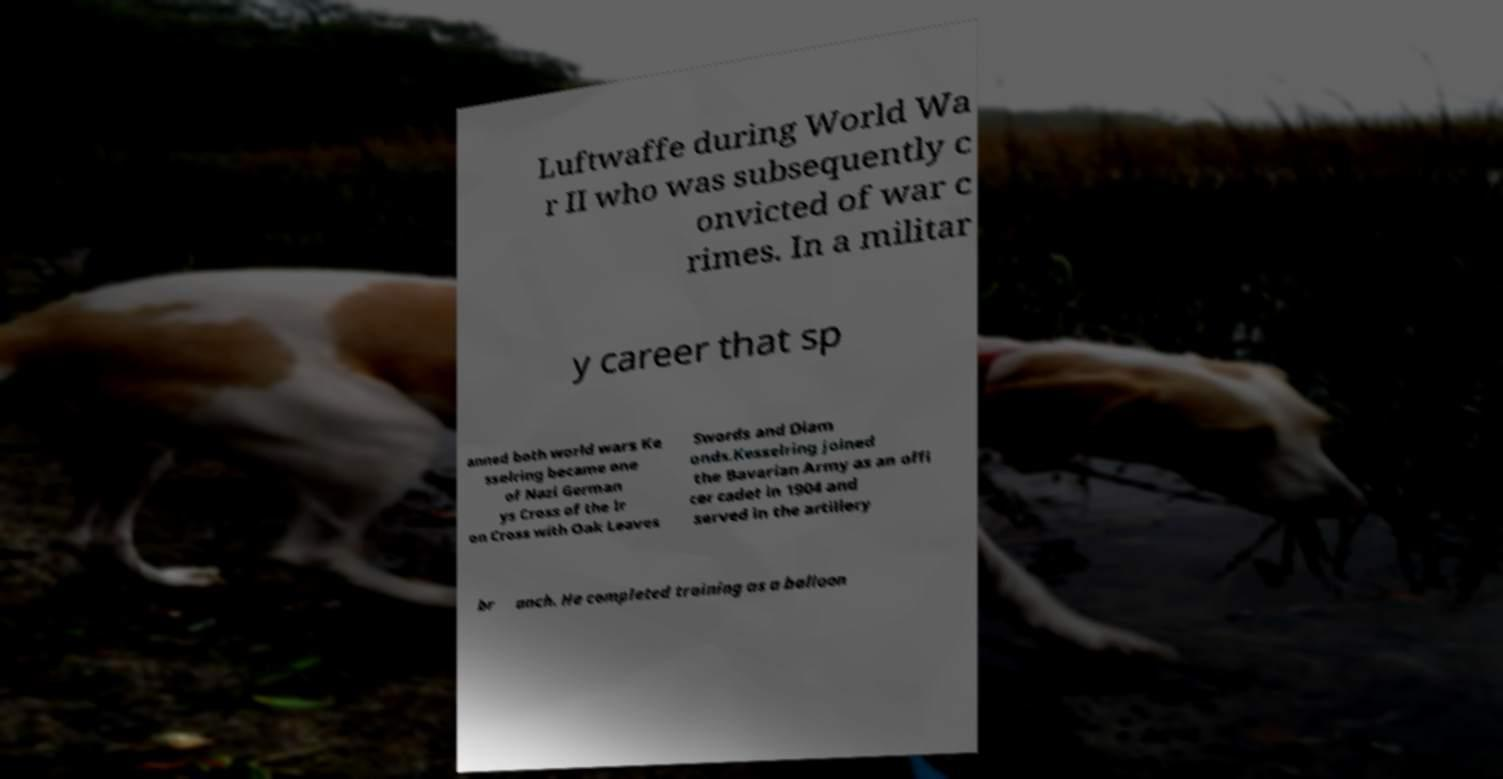Could you extract and type out the text from this image? Luftwaffe during World Wa r II who was subsequently c onvicted of war c rimes. In a militar y career that sp anned both world wars Ke sselring became one of Nazi German ys Cross of the Ir on Cross with Oak Leaves Swords and Diam onds.Kesselring joined the Bavarian Army as an offi cer cadet in 1904 and served in the artillery br anch. He completed training as a balloon 